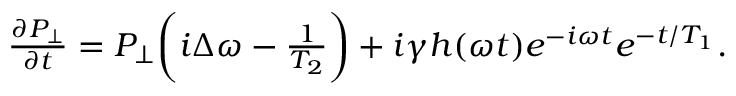Convert formula to latex. <formula><loc_0><loc_0><loc_500><loc_500>\begin{array} { r } { \frac { \partial P _ { \perp } } { \partial t } = P _ { \perp } \left ( i \Delta \omega - \frac { 1 } { T _ { 2 } } \right ) + i \gamma h ( \omega t ) e ^ { - i \omega t } e ^ { - t / T _ { 1 } } . } \end{array}</formula> 